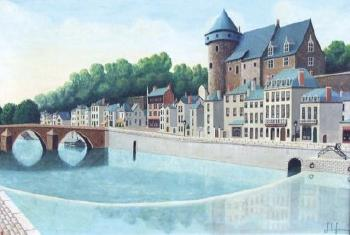Imagine the history of the castle-like structure in the image. What story might it tell? The castle-like structure in the image likely has a storied history dating back centuries. It might have originally been built as a fortification to protect the town from invaders, perched by the river to monitor any incoming threats. Over time, as the town grew and times of conflict subsided, the castle could have been converted into a residence for nobility. Stories of grand feasts, balls, and royal gatherings could echo through its halls. Today, it may serve as a historic monument, attracting tourists who are eager to explore its ancient corridors and learn about the tales of love, war, and politics that shaped its past. If there were a festival in this town, what kind of festivities and activities might you expect? During a festival, the town would likely come alive with vibrant decorations adorning the streets and buildings. Stalls selling local crafts, foods, and souvenirs might line the riverbanks and bridges. Traditional music could fill the air as local bands perform and people dance in the town square. There could be historical reenactments, especially around the castle, bringing to life the rich history of the town. Boat rides on the river, games for children, and a firework display over the water in the evening might add to the festive atmosphere. The whole town would gather to celebrate, creating an unforgettable experience for both residents and visitors. 